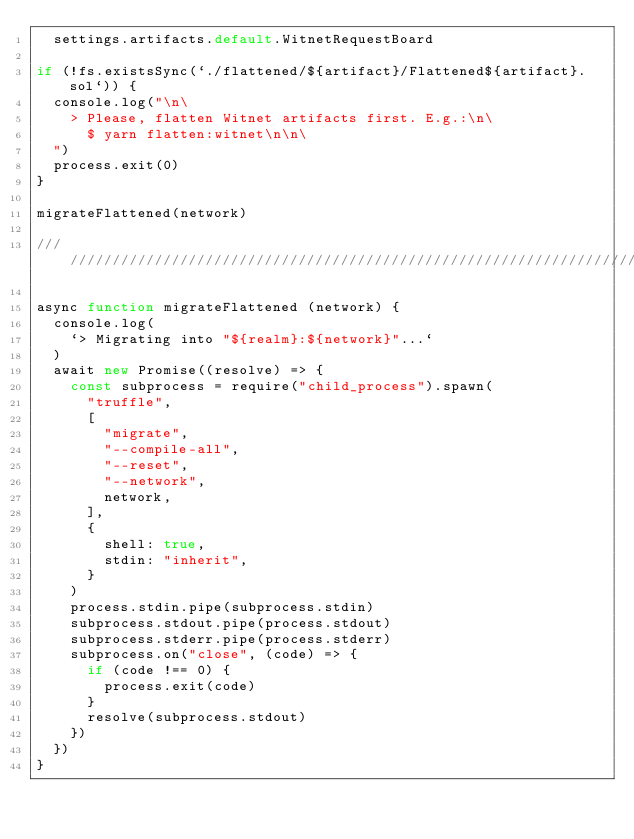<code> <loc_0><loc_0><loc_500><loc_500><_JavaScript_>  settings.artifacts.default.WitnetRequestBoard

if (!fs.existsSync(`./flattened/${artifact}/Flattened${artifact}.sol`)) {
  console.log("\n\
    > Please, flatten Witnet artifacts first. E.g.:\n\
      $ yarn flatten:witnet\n\n\
  ")
  process.exit(0)
}

migrateFlattened(network)

/// ///////////////////////////////////////////////////////////////////////////////

async function migrateFlattened (network) {
  console.log(
    `> Migrating into "${realm}:${network}"...`
  )
  await new Promise((resolve) => {
    const subprocess = require("child_process").spawn(
      "truffle",
      [
        "migrate",
        "--compile-all",
        "--reset",
        "--network",
        network,
      ],
      {
        shell: true,
        stdin: "inherit",
      }
    )
    process.stdin.pipe(subprocess.stdin)
    subprocess.stdout.pipe(process.stdout)
    subprocess.stderr.pipe(process.stderr)
    subprocess.on("close", (code) => {
      if (code !== 0) {
        process.exit(code)
      }
      resolve(subprocess.stdout)
    })
  })
}
</code> 